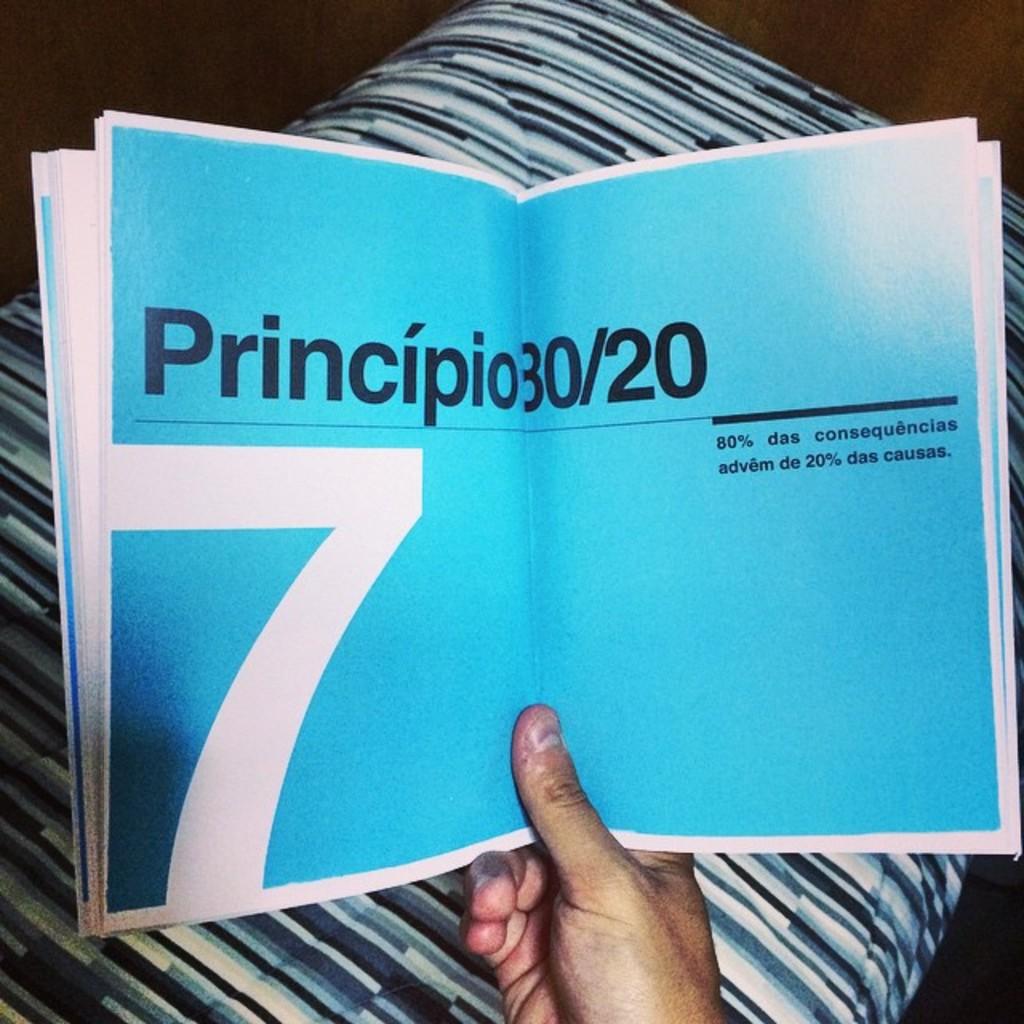What chapter is the book open to?
Give a very brief answer. 7. What is the big word?
Keep it short and to the point. Principio. 